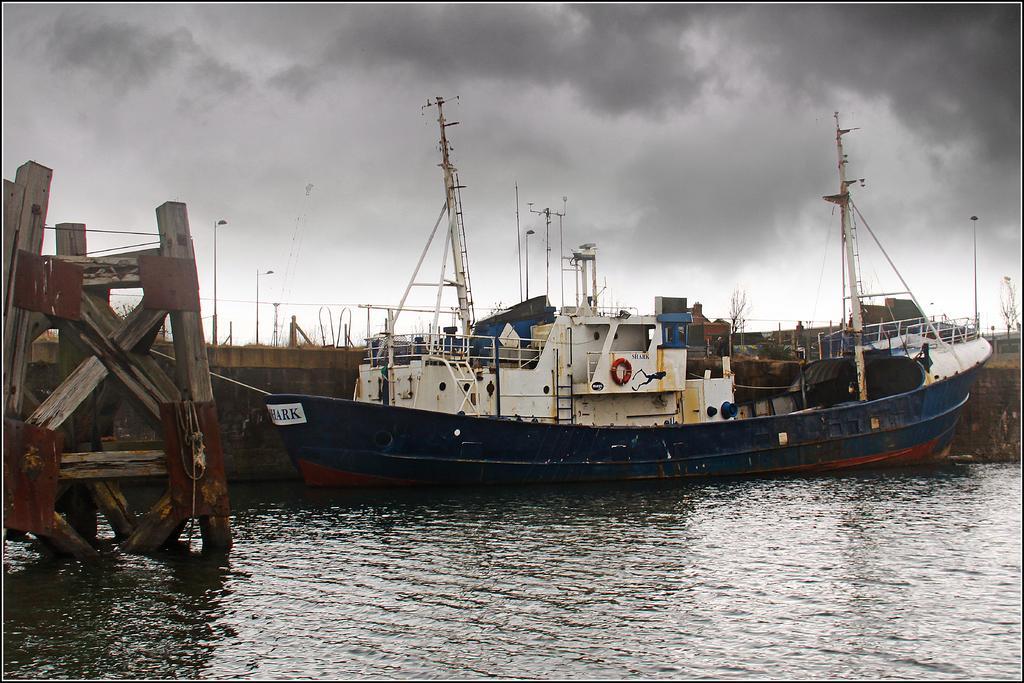Please provide a concise description of this image. The picture consists of a water body. In the center of the picture there are ships, a wooden construction and other materials. Sky is cloudy. 